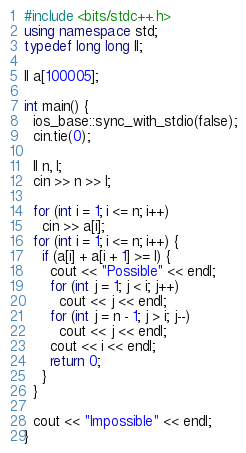<code> <loc_0><loc_0><loc_500><loc_500><_C++_>#include <bits/stdc++.h>
using namespace std;
typedef long long ll;

ll a[100005];

int main() {
  ios_base::sync_with_stdio(false);
  cin.tie(0);

  ll n, l;
  cin >> n >> l;

  for (int i = 1; i <= n; i++)
    cin >> a[i];
  for (int i = 1; i <= n; i++) {
    if (a[i] + a[i + 1] >= l) {
      cout << "Possible" << endl;
      for (int j = 1; j < i; j++)
        cout << j << endl;
      for (int j = n - 1; j > i; j--)
        cout << j << endl;
      cout << i << endl;
      return 0;
    }
  }

  cout << "Impossible" << endl;
}
</code> 